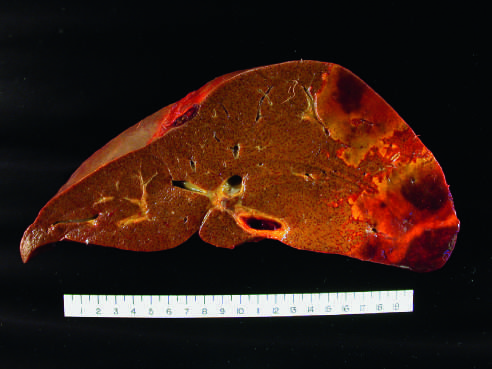s the embolus pale, with a hemorrhagic margin?
Answer the question using a single word or phrase. No 